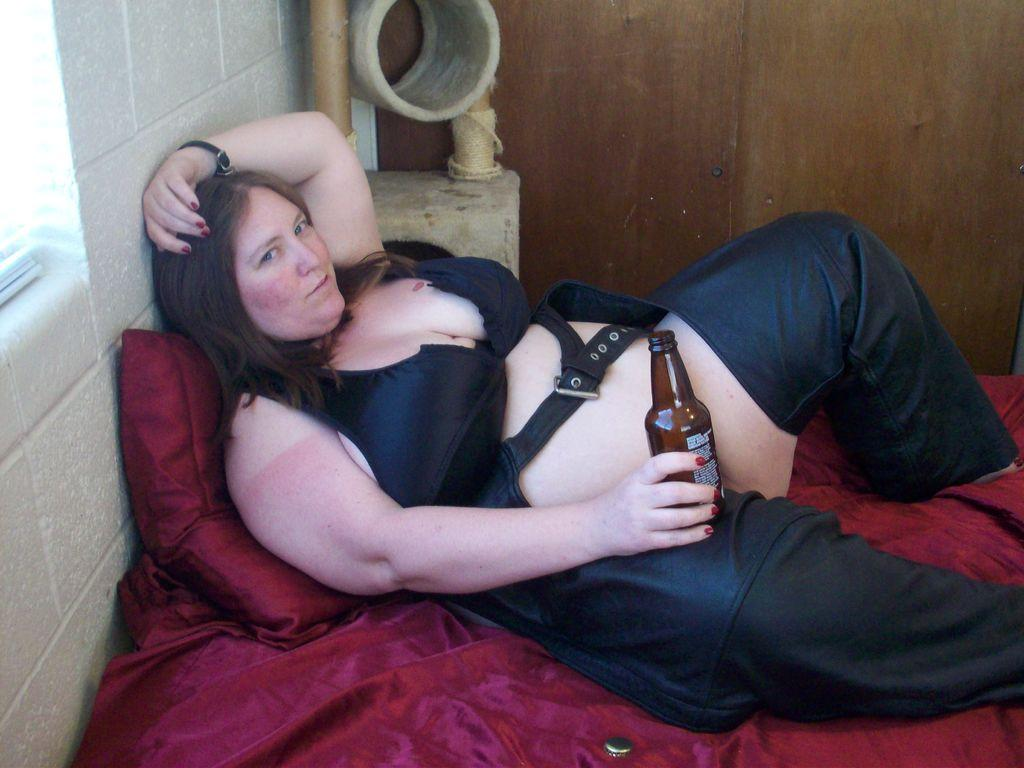Who is present in the image? There is a woman in the image. What is the woman doing in the image? The woman is laying on a bed. What object is visible on the bed? There is a pillow in the image. What is the woman wearing in the image? The woman is wearing a black dress. What is the woman holding in the image? The woman is holding a bottle. How many ladybugs are crawling on the wall in the image? There are no ladybugs present in the image, nor is there a wall visible. 